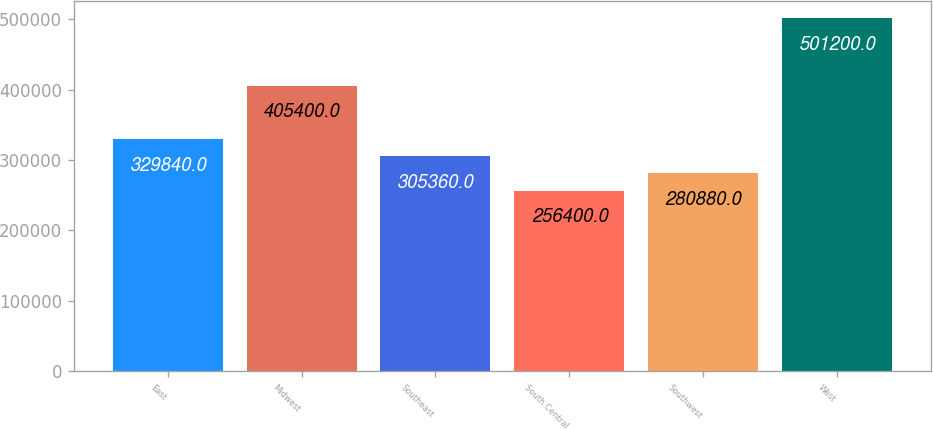Convert chart to OTSL. <chart><loc_0><loc_0><loc_500><loc_500><bar_chart><fcel>East<fcel>Midwest<fcel>Southeast<fcel>South Central<fcel>Southwest<fcel>West<nl><fcel>329840<fcel>405400<fcel>305360<fcel>256400<fcel>280880<fcel>501200<nl></chart> 